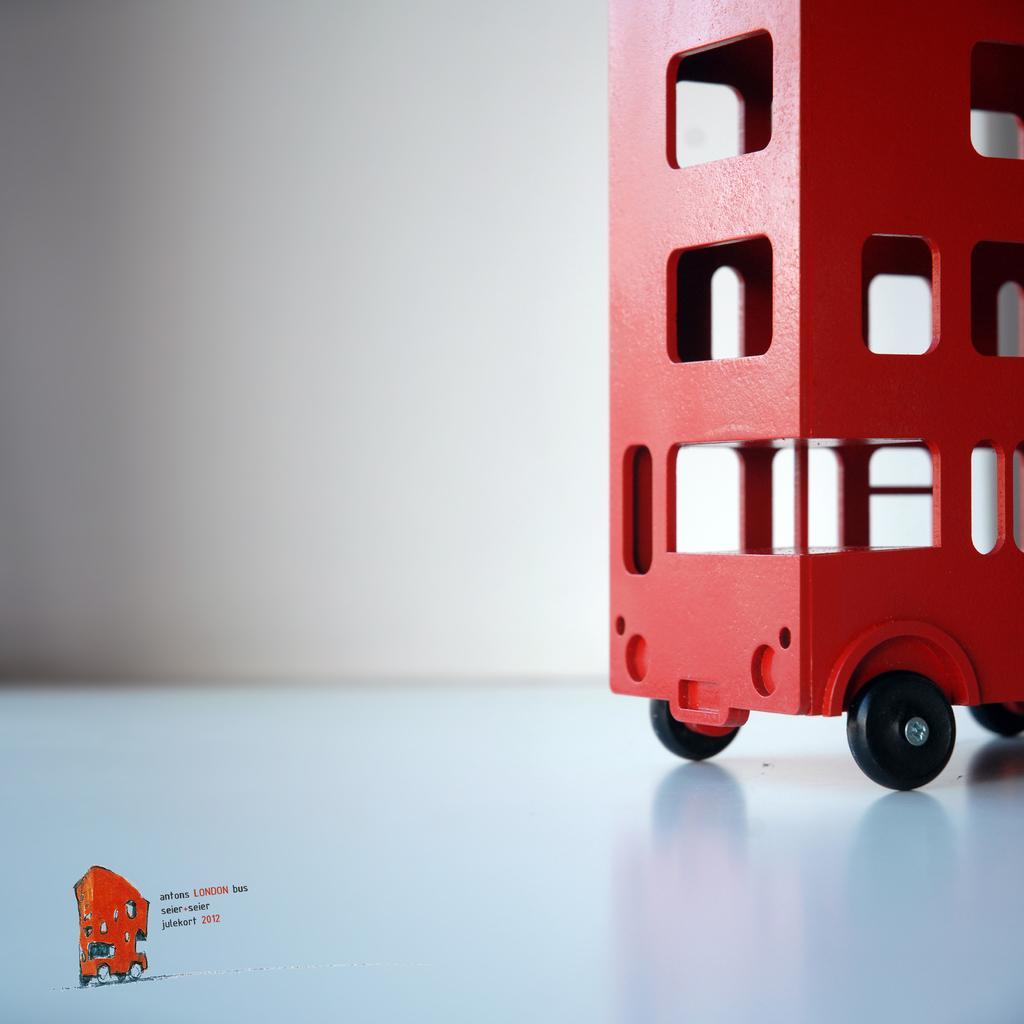In one or two sentences, can you explain what this image depicts? In this image, on the right side, we can see a toy vehicle which is placed on the table. In the background, we can see a wall. 